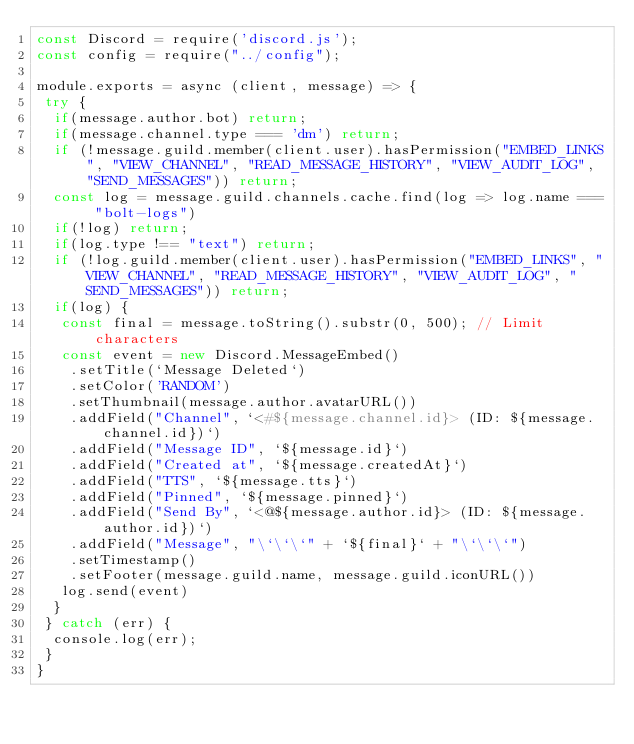<code> <loc_0><loc_0><loc_500><loc_500><_JavaScript_>const Discord = require('discord.js');
const config = require("../config");

module.exports = async (client, message) => {
 try {
  if(message.author.bot) return;
  if(message.channel.type === 'dm') return;
  if (!message.guild.member(client.user).hasPermission("EMBED_LINKS", "VIEW_CHANNEL", "READ_MESSAGE_HISTORY", "VIEW_AUDIT_LOG", "SEND_MESSAGES")) return;
  const log = message.guild.channels.cache.find(log => log.name === "bolt-logs")
  if(!log) return;
  if(log.type !== "text") return;
  if (!log.guild.member(client.user).hasPermission("EMBED_LINKS", "VIEW_CHANNEL", "READ_MESSAGE_HISTORY", "VIEW_AUDIT_LOG", "SEND_MESSAGES")) return;
  if(log) {
   const final = message.toString().substr(0, 500); // Limit characters
   const event = new Discord.MessageEmbed()
    .setTitle(`Message Deleted`)
    .setColor('RANDOM')
    .setThumbnail(message.author.avatarURL())
    .addField("Channel", `<#${message.channel.id}> (ID: ${message.channel.id})`)
    .addField("Message ID", `${message.id}`)
    .addField("Created at", `${message.createdAt}`)
    .addField("TTS", `${message.tts}`)
    .addField("Pinned", `${message.pinned}`)
    .addField("Send By", `<@${message.author.id}> (ID: ${message.author.id})`)
    .addField("Message", "\`\`\`" + `${final}` + "\`\`\`")
    .setTimestamp()
    .setFooter(message.guild.name, message.guild.iconURL())
   log.send(event)
  }
 } catch (err) {
  console.log(err);
 }
}
</code> 